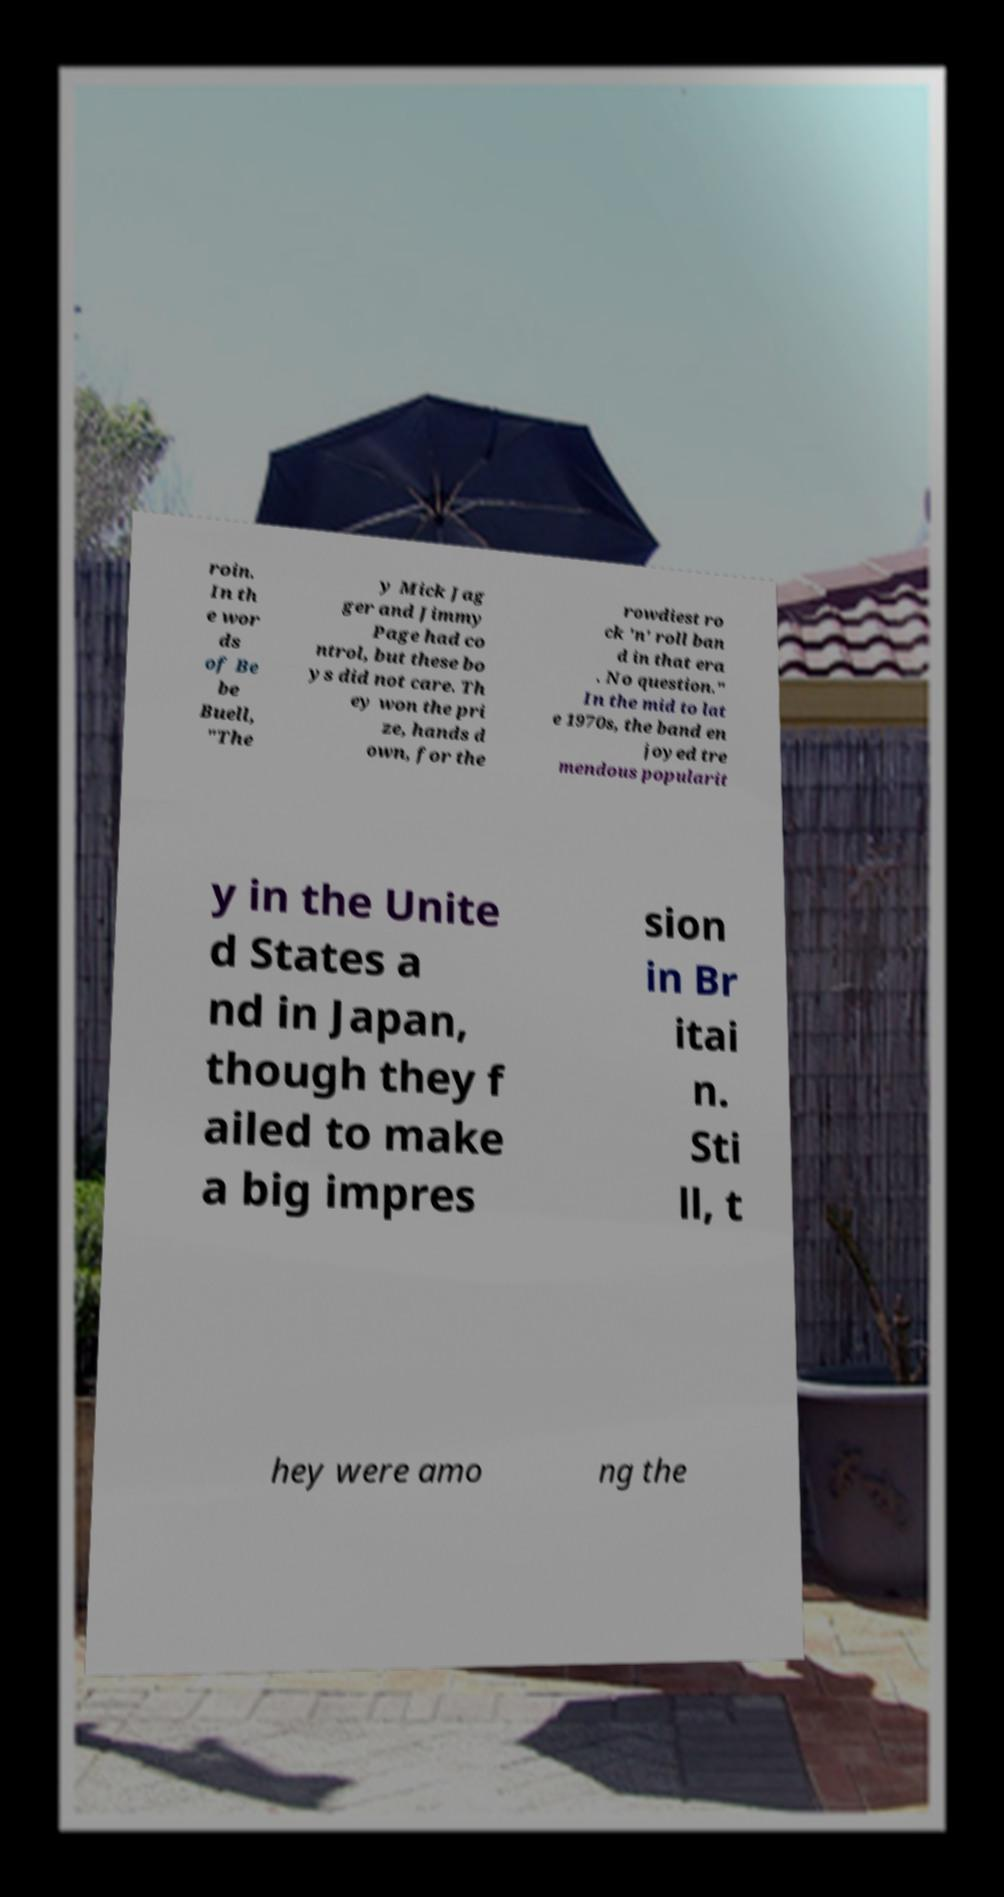Could you assist in decoding the text presented in this image and type it out clearly? roin. In th e wor ds of Be be Buell, "The y Mick Jag ger and Jimmy Page had co ntrol, but these bo ys did not care. Th ey won the pri ze, hands d own, for the rowdiest ro ck 'n' roll ban d in that era . No question." In the mid to lat e 1970s, the band en joyed tre mendous popularit y in the Unite d States a nd in Japan, though they f ailed to make a big impres sion in Br itai n. Sti ll, t hey were amo ng the 